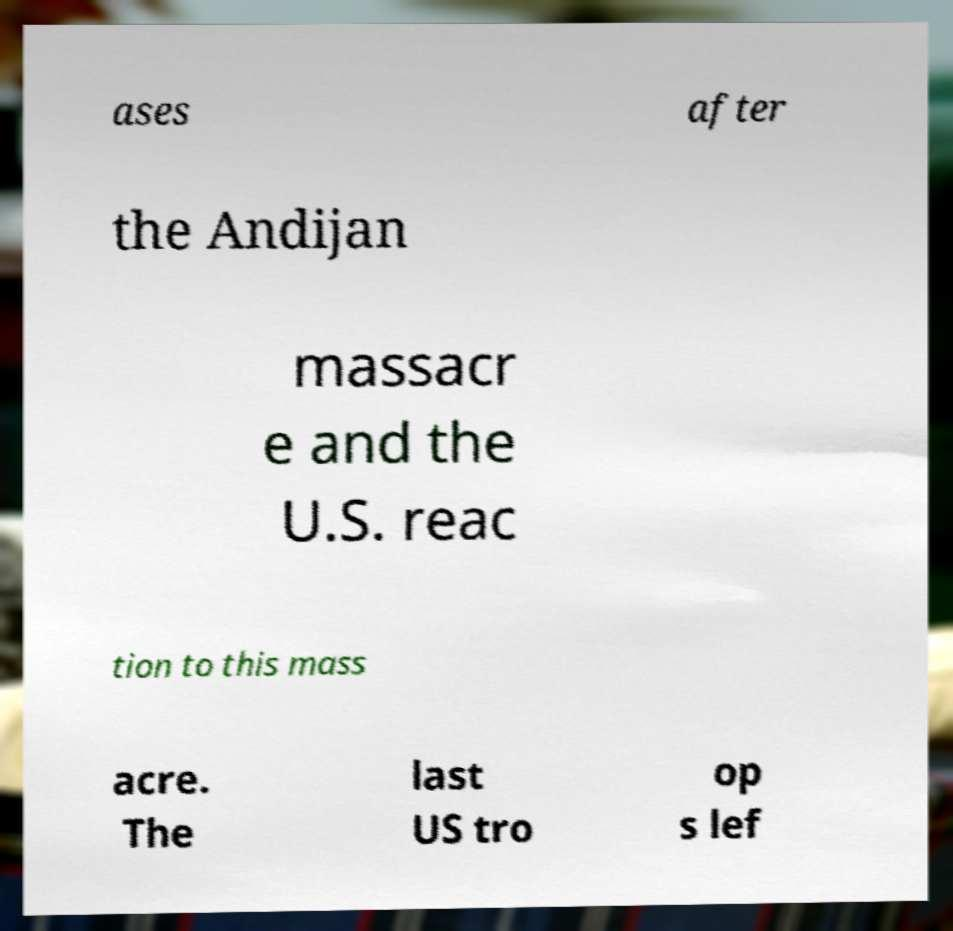Please read and relay the text visible in this image. What does it say? ases after the Andijan massacr e and the U.S. reac tion to this mass acre. The last US tro op s lef 